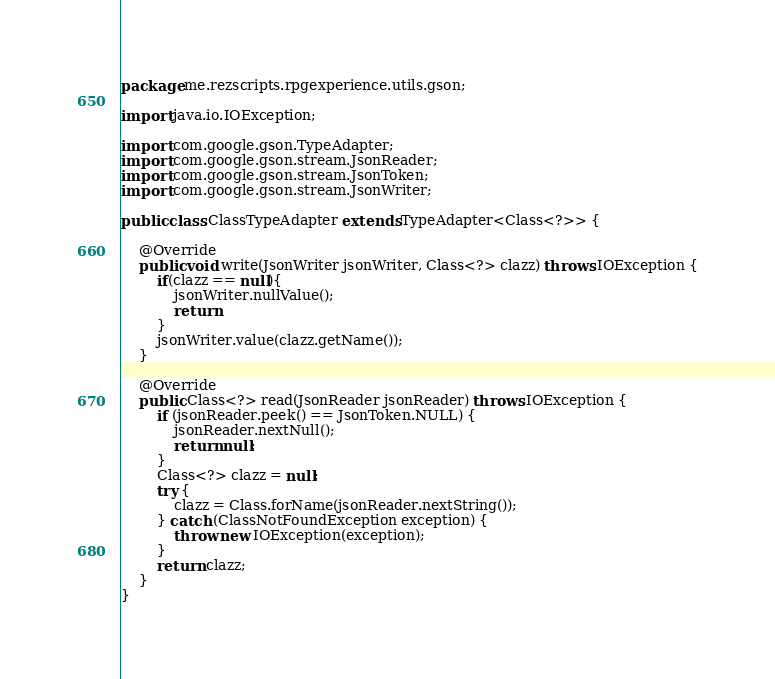Convert code to text. <code><loc_0><loc_0><loc_500><loc_500><_Java_>package me.rezscripts.rpgexperience.utils.gson;

import java.io.IOException;

import com.google.gson.TypeAdapter;
import com.google.gson.stream.JsonReader;
import com.google.gson.stream.JsonToken;
import com.google.gson.stream.JsonWriter;

public class ClassTypeAdapter extends TypeAdapter<Class<?>> {
    
    @Override
    public void write(JsonWriter jsonWriter, Class<?> clazz) throws IOException {
        if(clazz == null){
            jsonWriter.nullValue();
            return;
        }
        jsonWriter.value(clazz.getName());
    }

    @Override
    public Class<?> read(JsonReader jsonReader) throws IOException {
        if (jsonReader.peek() == JsonToken.NULL) {
            jsonReader.nextNull();
            return null;
        }
        Class<?> clazz = null;
        try {
            clazz = Class.forName(jsonReader.nextString());
        } catch (ClassNotFoundException exception) {
            throw new IOException(exception);
        }
        return clazz;
    }
}</code> 